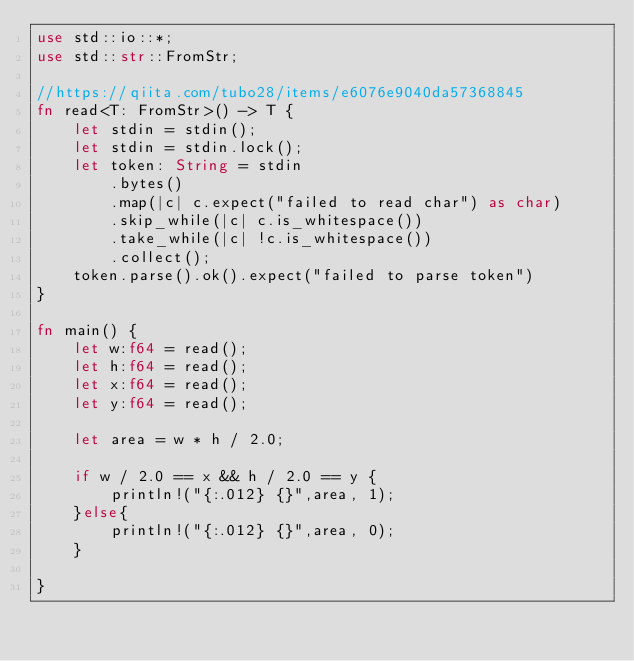Convert code to text. <code><loc_0><loc_0><loc_500><loc_500><_Rust_>use std::io::*;
use std::str::FromStr;

//https://qiita.com/tubo28/items/e6076e9040da57368845
fn read<T: FromStr>() -> T {
    let stdin = stdin();
    let stdin = stdin.lock();
    let token: String = stdin
        .bytes()
        .map(|c| c.expect("failed to read char") as char)
        .skip_while(|c| c.is_whitespace())
        .take_while(|c| !c.is_whitespace())
        .collect();
    token.parse().ok().expect("failed to parse token")
}

fn main() {
    let w:f64 = read();
    let h:f64 = read();
    let x:f64 = read();
    let y:f64 = read();

    let area = w * h / 2.0;

    if w / 2.0 == x && h / 2.0 == y {
        println!("{:.012} {}",area, 1);
    }else{
        println!("{:.012} {}",area, 0);
    }

}
</code> 